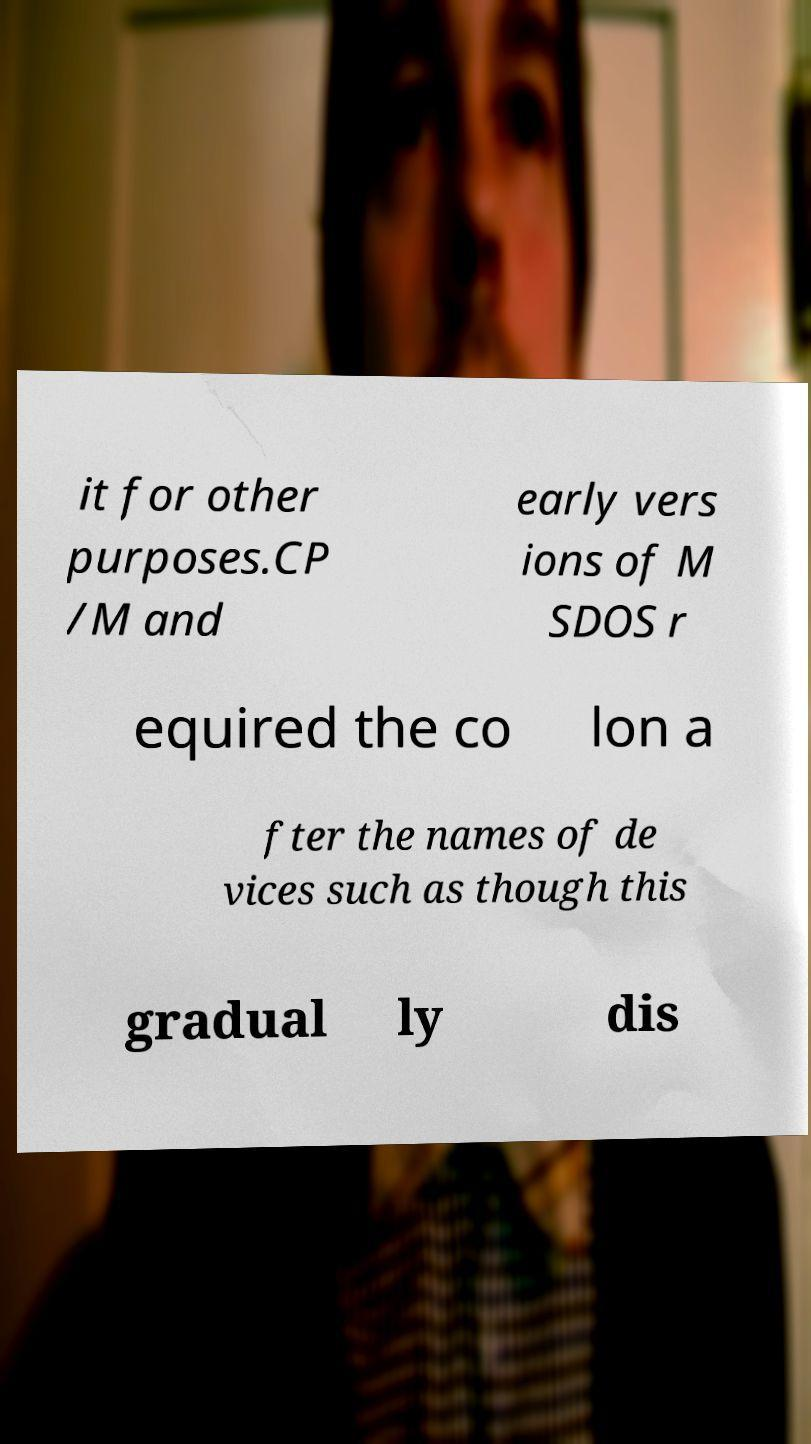Please read and relay the text visible in this image. What does it say? it for other purposes.CP /M and early vers ions of M SDOS r equired the co lon a fter the names of de vices such as though this gradual ly dis 